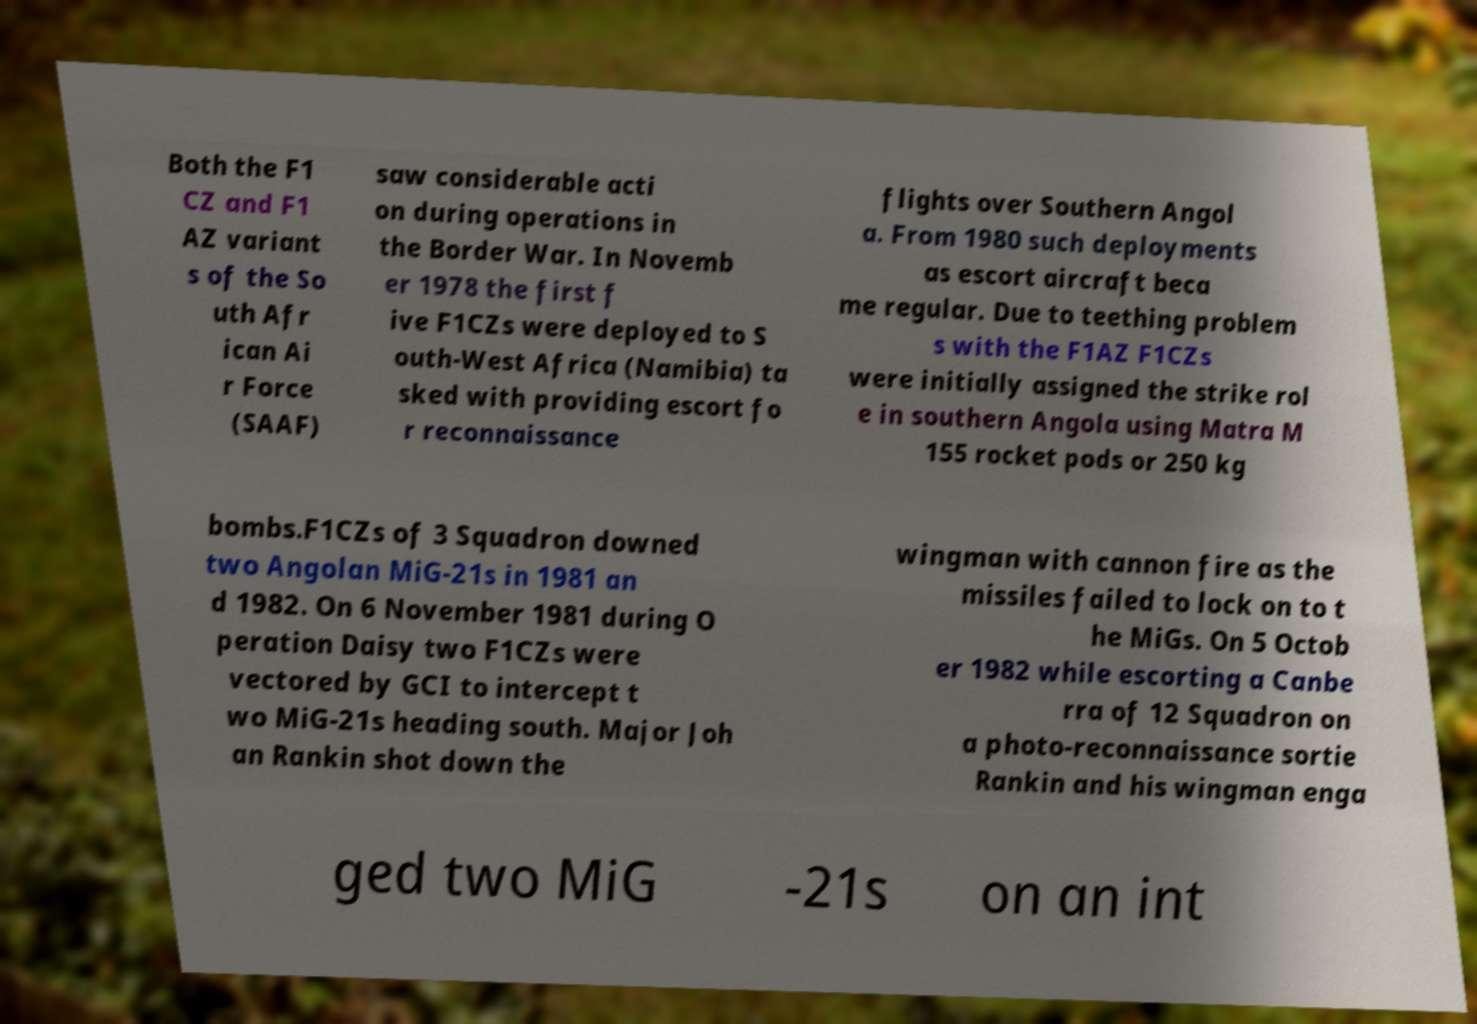For documentation purposes, I need the text within this image transcribed. Could you provide that? Both the F1 CZ and F1 AZ variant s of the So uth Afr ican Ai r Force (SAAF) saw considerable acti on during operations in the Border War. In Novemb er 1978 the first f ive F1CZs were deployed to S outh-West Africa (Namibia) ta sked with providing escort fo r reconnaissance flights over Southern Angol a. From 1980 such deployments as escort aircraft beca me regular. Due to teething problem s with the F1AZ F1CZs were initially assigned the strike rol e in southern Angola using Matra M 155 rocket pods or 250 kg bombs.F1CZs of 3 Squadron downed two Angolan MiG-21s in 1981 an d 1982. On 6 November 1981 during O peration Daisy two F1CZs were vectored by GCI to intercept t wo MiG-21s heading south. Major Joh an Rankin shot down the wingman with cannon fire as the missiles failed to lock on to t he MiGs. On 5 Octob er 1982 while escorting a Canbe rra of 12 Squadron on a photo-reconnaissance sortie Rankin and his wingman enga ged two MiG -21s on an int 